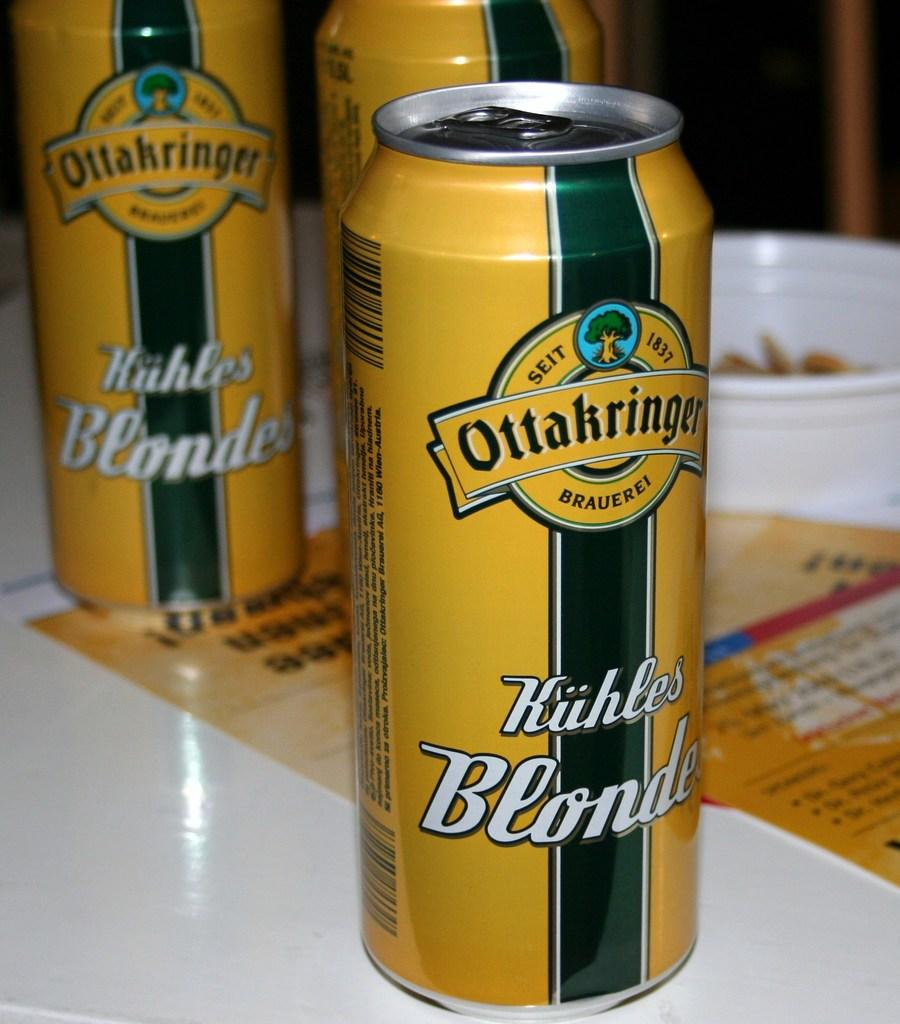<image>
Offer a succinct explanation of the picture presented. A yellow can of Ottakringer Kuhles Blonde drink on top of a table. 